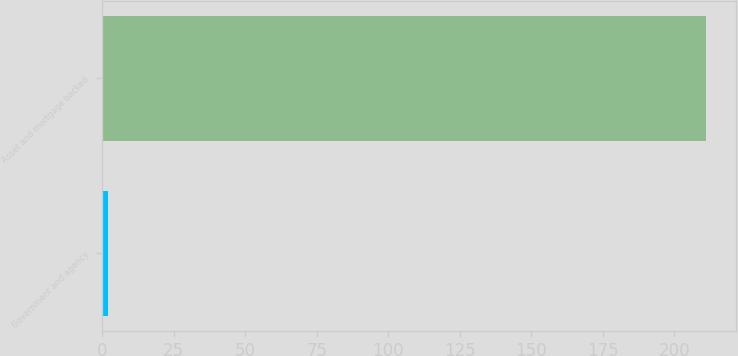Convert chart to OTSL. <chart><loc_0><loc_0><loc_500><loc_500><bar_chart><fcel>Government and agency<fcel>Asset and mortgage backed<nl><fcel>2<fcel>211<nl></chart> 